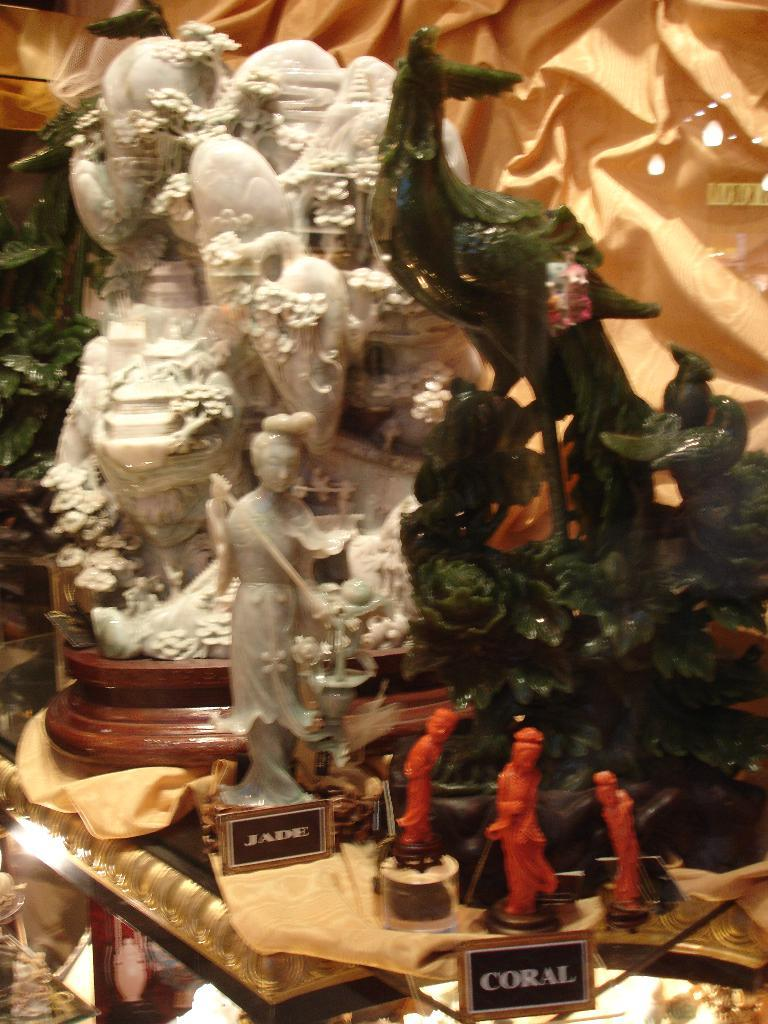What type of objects can be seen in the image? There are idols and statues in the image. What is present behind the idols and statues? There is a cloth behind the idols and statues. How many dimes are scattered around the idols and statues in the image? There are no dimes present in the image; it only features idols, statues, and a cloth. 